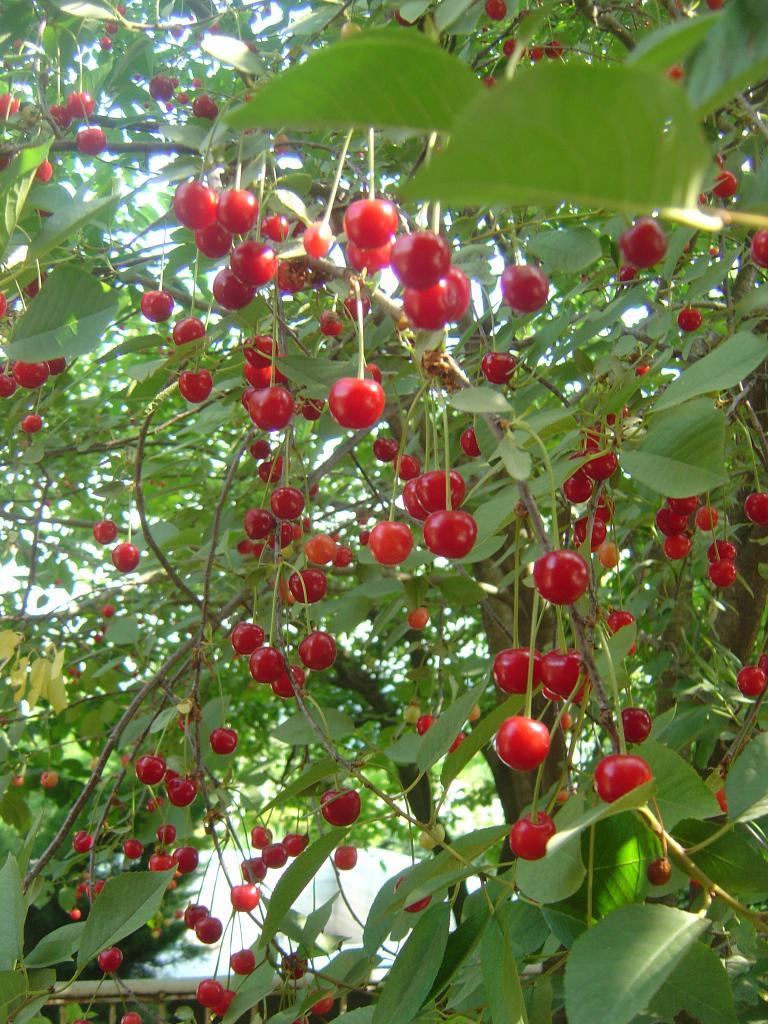What type of food can be seen in the image? There are fruits in the image. What natural elements are present in the image? There are trees in the image. What type of button can be seen on the holiday decoration in the image? There is no holiday decoration or button present in the image; it only features fruits and trees. Can you describe the smile of the person in the image? There is no person present in the image, so it is not possible to describe a smile. 